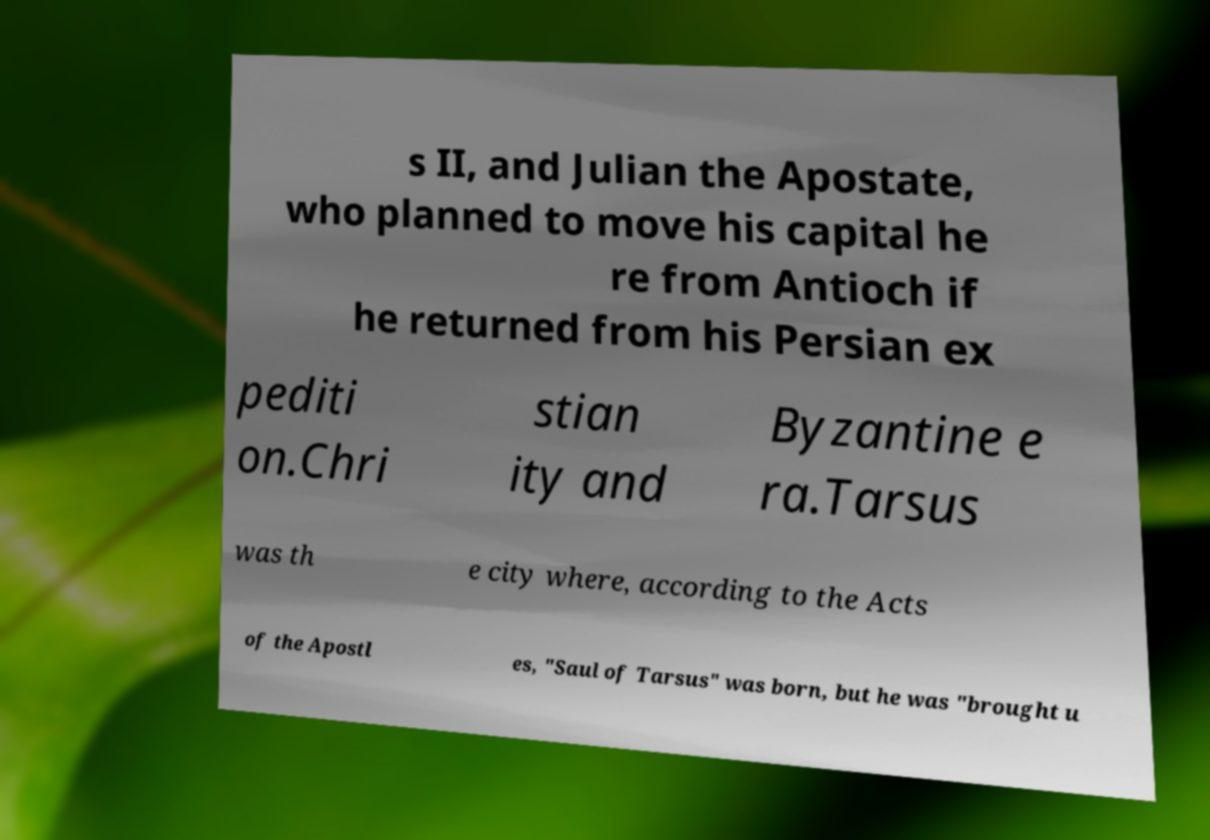Could you assist in decoding the text presented in this image and type it out clearly? s II, and Julian the Apostate, who planned to move his capital he re from Antioch if he returned from his Persian ex pediti on.Chri stian ity and Byzantine e ra.Tarsus was th e city where, according to the Acts of the Apostl es, "Saul of Tarsus" was born, but he was "brought u 